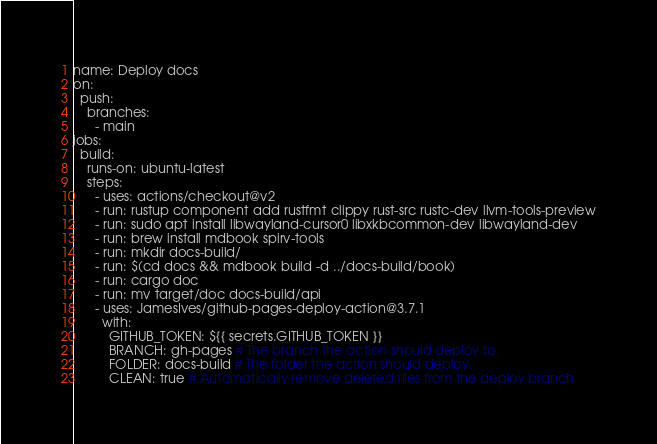Convert code to text. <code><loc_0><loc_0><loc_500><loc_500><_YAML_>name: Deploy docs
on:
  push:
    branches:
      - main
jobs:
  build:
    runs-on: ubuntu-latest
    steps:
      - uses: actions/checkout@v2
      - run: rustup component add rustfmt clippy rust-src rustc-dev llvm-tools-preview
      - run: sudo apt install libwayland-cursor0 libxkbcommon-dev libwayland-dev
      - run: brew install mdbook spirv-tools
      - run: mkdir docs-build/
      - run: $(cd docs && mdbook build -d ../docs-build/book)
      - run: cargo doc
      - run: mv target/doc docs-build/api
      - uses: JamesIves/github-pages-deploy-action@3.7.1
        with:
          GITHUB_TOKEN: ${{ secrets.GITHUB_TOKEN }}
          BRANCH: gh-pages # The branch the action should deploy to.
          FOLDER: docs-build # The folder the action should deploy.
          CLEAN: true # Automatically remove deleted files from the deploy branch
</code> 